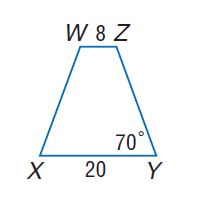Answer the mathemtical geometry problem and directly provide the correct option letter.
Question: For isosceles trapezoid X Y Z W, find m \angle Z.
Choices: A: 70 B: 90 C: 110 D: 250 C 